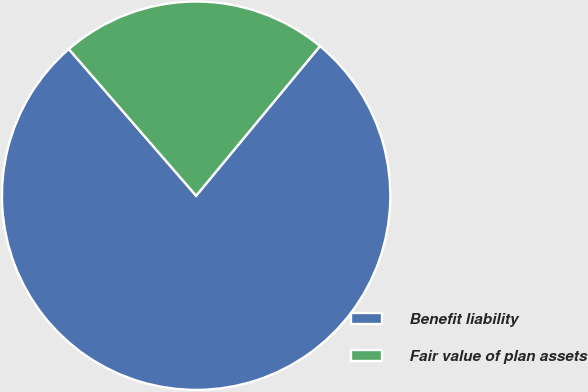Convert chart. <chart><loc_0><loc_0><loc_500><loc_500><pie_chart><fcel>Benefit liability<fcel>Fair value of plan assets<nl><fcel>77.62%<fcel>22.38%<nl></chart> 